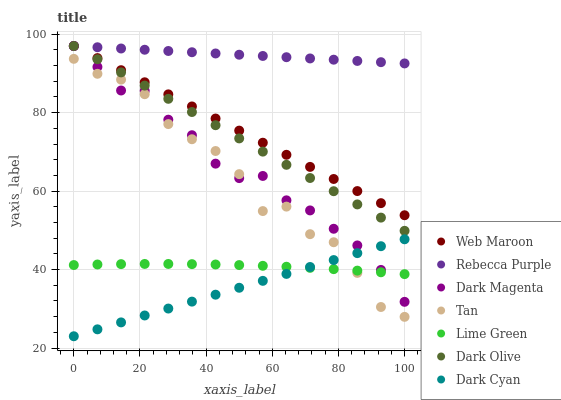Does Dark Cyan have the minimum area under the curve?
Answer yes or no. Yes. Does Rebecca Purple have the maximum area under the curve?
Answer yes or no. Yes. Does Dark Olive have the minimum area under the curve?
Answer yes or no. No. Does Dark Olive have the maximum area under the curve?
Answer yes or no. No. Is Dark Cyan the smoothest?
Answer yes or no. Yes. Is Tan the roughest?
Answer yes or no. Yes. Is Dark Olive the smoothest?
Answer yes or no. No. Is Dark Olive the roughest?
Answer yes or no. No. Does Dark Cyan have the lowest value?
Answer yes or no. Yes. Does Dark Olive have the lowest value?
Answer yes or no. No. Does Rebecca Purple have the highest value?
Answer yes or no. Yes. Does Dark Cyan have the highest value?
Answer yes or no. No. Is Lime Green less than Dark Olive?
Answer yes or no. Yes. Is Web Maroon greater than Dark Cyan?
Answer yes or no. Yes. Does Tan intersect Lime Green?
Answer yes or no. Yes. Is Tan less than Lime Green?
Answer yes or no. No. Is Tan greater than Lime Green?
Answer yes or no. No. Does Lime Green intersect Dark Olive?
Answer yes or no. No. 